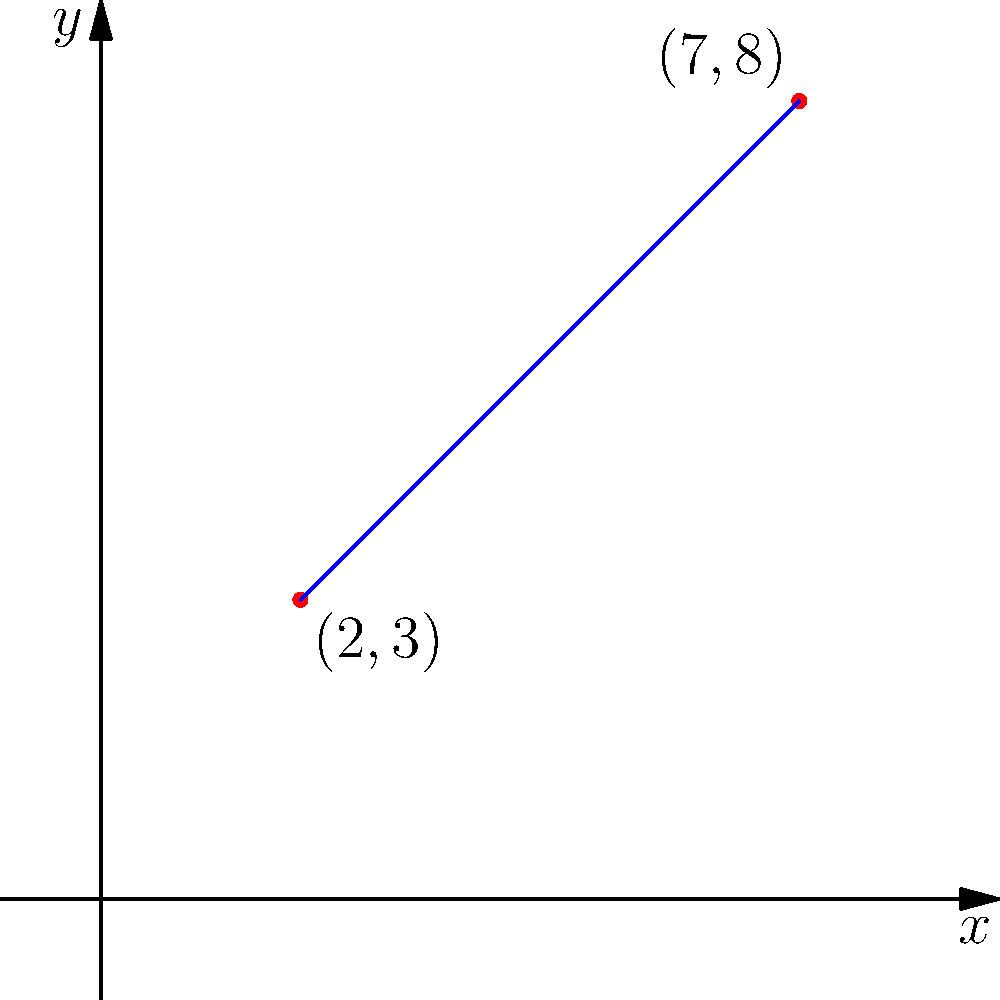Given two points on a coordinate plane, (2,3) and (7,8), calculate the slope of the line passing through these points. Provide a comprehensive explanation of the slope formula and its application in this context, including any potential implications for Android UI design where such calculations might be relevant. To calculate the slope of a line given two points, we employ the slope formula, which is a fundamental concept in analytic geometry. Let's break this down step-by-step:

1. Slope Formula:
   The slope (m) of a line passing through two points $(x_1, y_1)$ and $(x_2, y_2)$ is given by:
   
   $$ m = \frac{y_2 - y_1}{x_2 - x_1} $$

   This formula represents the change in y-coordinates divided by the change in x-coordinates.

2. Identifying our points:
   In our case, we have:
   $(x_1, y_1) = (2, 3)$
   $(x_2, y_2) = (7, 8)$

3. Plugging into the formula:
   $$ m = \frac{8 - 3}{7 - 2} = \frac{5}{5} = 1 $$

4. Interpretation:
   A slope of 1 means that for every unit increase in x, y also increases by 1 unit. This results in a 45-degree angle line (if the x and y scales are the same).

5. Verification:
   We can verify this visually on the graph. Moving from (2,3) to (7,8), we indeed see that both x and y increase by 5 units.

6. Android UI Relevance:
   In Android development, understanding slope calculations can be crucial for various UI design aspects:
   
   a) Custom View Drawing: When creating custom views or animations, you might need to calculate slopes to draw lines or determine trajectories.
   
   b) Gesture Recognition: Slope calculations can be used in interpreting touch gestures, such as determining if a swipe is more horizontal or vertical.
   
   c) Responsive Layouts: When designing responsive layouts that need to scale proportionally across different screen sizes, slope concepts can be applied to maintain aspect ratios.
   
   d) Data Visualization: If you're implementing data visualization components in your Android app, slope calculations are fundamental for plotting trend lines or other linear representations of data.

7. Efficiency Considerations:
   While the slope formula is straightforward, in performance-critical Android applications, you might consider optimizing calculations, especially if dealing with real-time computations or large datasets. For instance, you could pre-compute slopes for common scenarios or use lookup tables for frequently used values.

In conclusion, the slope of the line passing through (2,3) and (7,8) is 1, indicating a perfect diagonal in a square coordinate system. This concept, while seemingly simple, has far-reaching applications in various aspects of computer science and Android development, from basic UI design to complex data analysis and visualization tasks.
Answer: $m = 1$ 